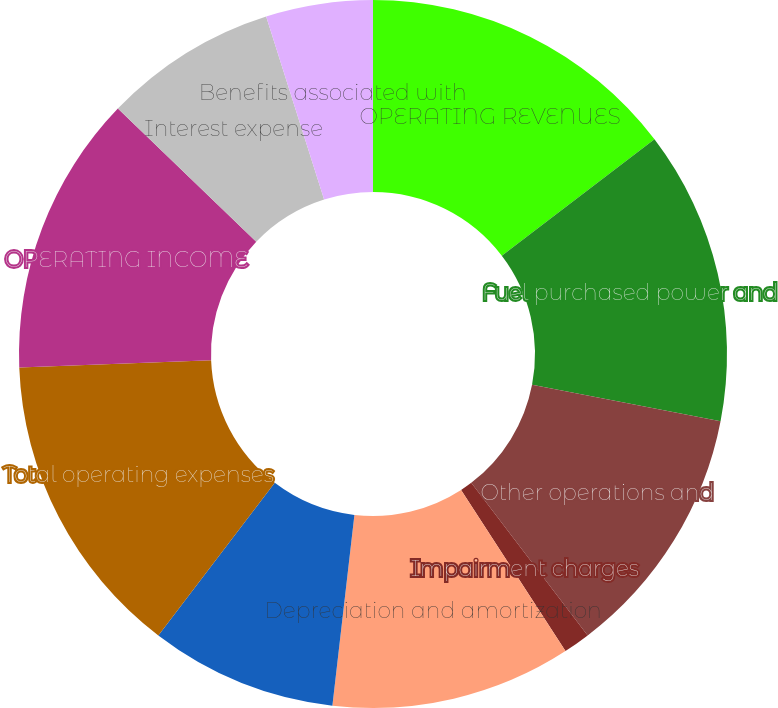Convert chart. <chart><loc_0><loc_0><loc_500><loc_500><pie_chart><fcel>OPERATING REVENUES<fcel>Fuel purchased power and<fcel>Other operations and<fcel>Impairment charges<fcel>Depreciation and amortization<fcel>Taxes other than income taxes<fcel>Total operating expenses<fcel>OPERATING INCOME<fcel>Interest expense<fcel>Benefits associated with<nl><fcel>14.63%<fcel>13.41%<fcel>11.59%<fcel>1.22%<fcel>10.98%<fcel>8.54%<fcel>14.02%<fcel>12.8%<fcel>7.93%<fcel>4.88%<nl></chart> 